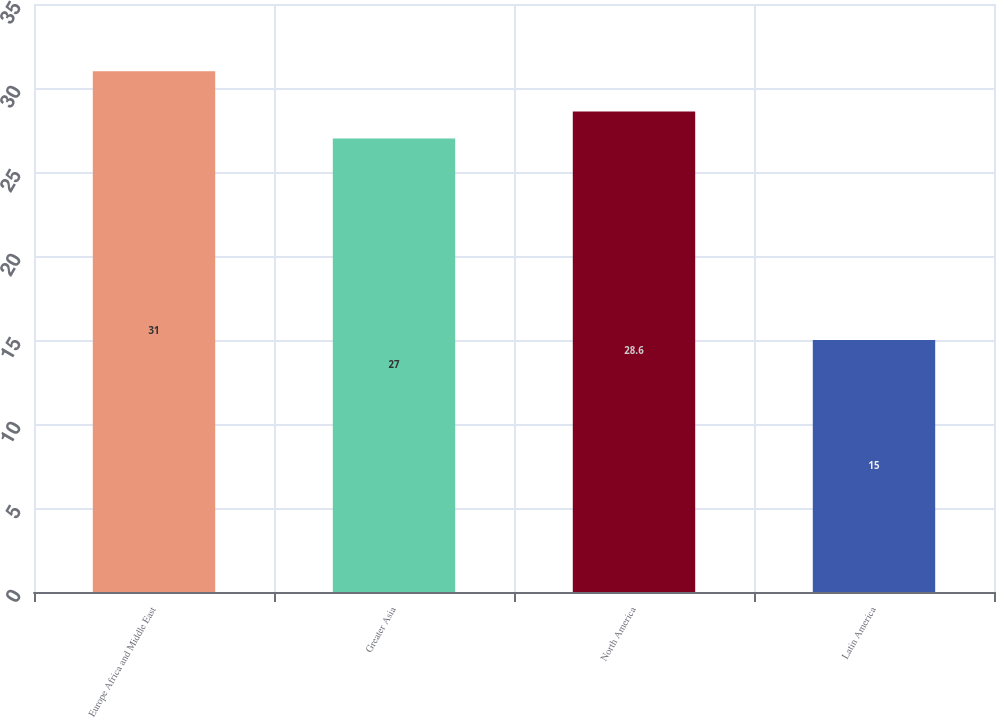Convert chart to OTSL. <chart><loc_0><loc_0><loc_500><loc_500><bar_chart><fcel>Europe Africa and Middle East<fcel>Greater Asia<fcel>North America<fcel>Latin America<nl><fcel>31<fcel>27<fcel>28.6<fcel>15<nl></chart> 